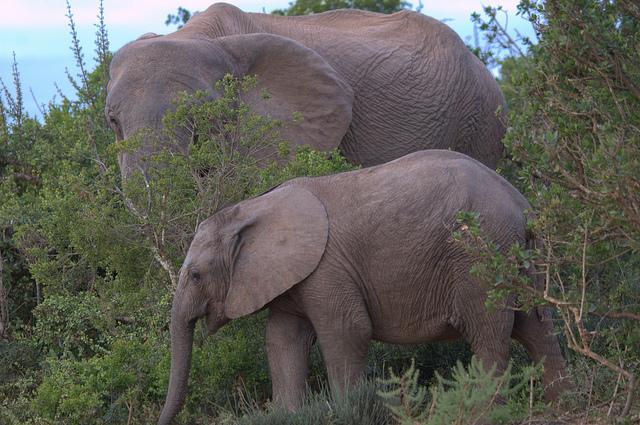Are the elephants gray?
Give a very brief answer. Yes. Are the elephants facing the same direction?
Give a very brief answer. Yes. How many elephants are here?
Be succinct. 2. Are the elephants going for a walk?
Keep it brief. Yes. How well are the elephants able to hide?
Be succinct. Not well. Do the elephants have dirt all over them?
Give a very brief answer. No. What are white and sharp on mammal?
Be succinct. Tusks. 